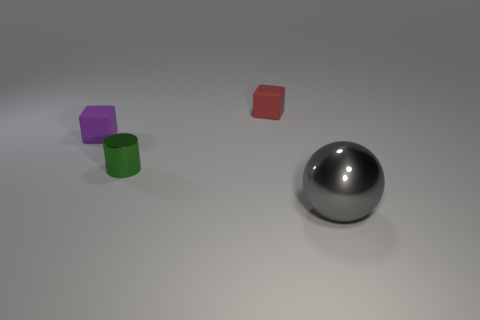Is the shape of the tiny object that is to the right of the tiny green object the same as the small matte thing that is on the left side of the tiny red block?
Give a very brief answer. Yes. How many objects are tiny blue cylinders or purple rubber objects that are to the left of the green cylinder?
Your answer should be compact. 1. What number of other things are the same size as the cylinder?
Ensure brevity in your answer.  2. Is the material of the thing right of the small red thing the same as the small thing that is in front of the tiny purple matte cube?
Give a very brief answer. Yes. There is a green metal object; what number of tiny red blocks are behind it?
Your response must be concise. 1. What number of red things are either tiny rubber objects or small metallic cylinders?
Offer a terse response. 1. There is a green cylinder that is the same size as the purple matte object; what is its material?
Your answer should be very brief. Metal. The object that is both on the right side of the green thing and behind the large gray thing has what shape?
Provide a short and direct response. Cube. There is a rubber cube that is the same size as the purple matte thing; what is its color?
Make the answer very short. Red. Does the thing that is left of the green metal cylinder have the same size as the matte cube to the right of the purple rubber object?
Provide a short and direct response. Yes. 